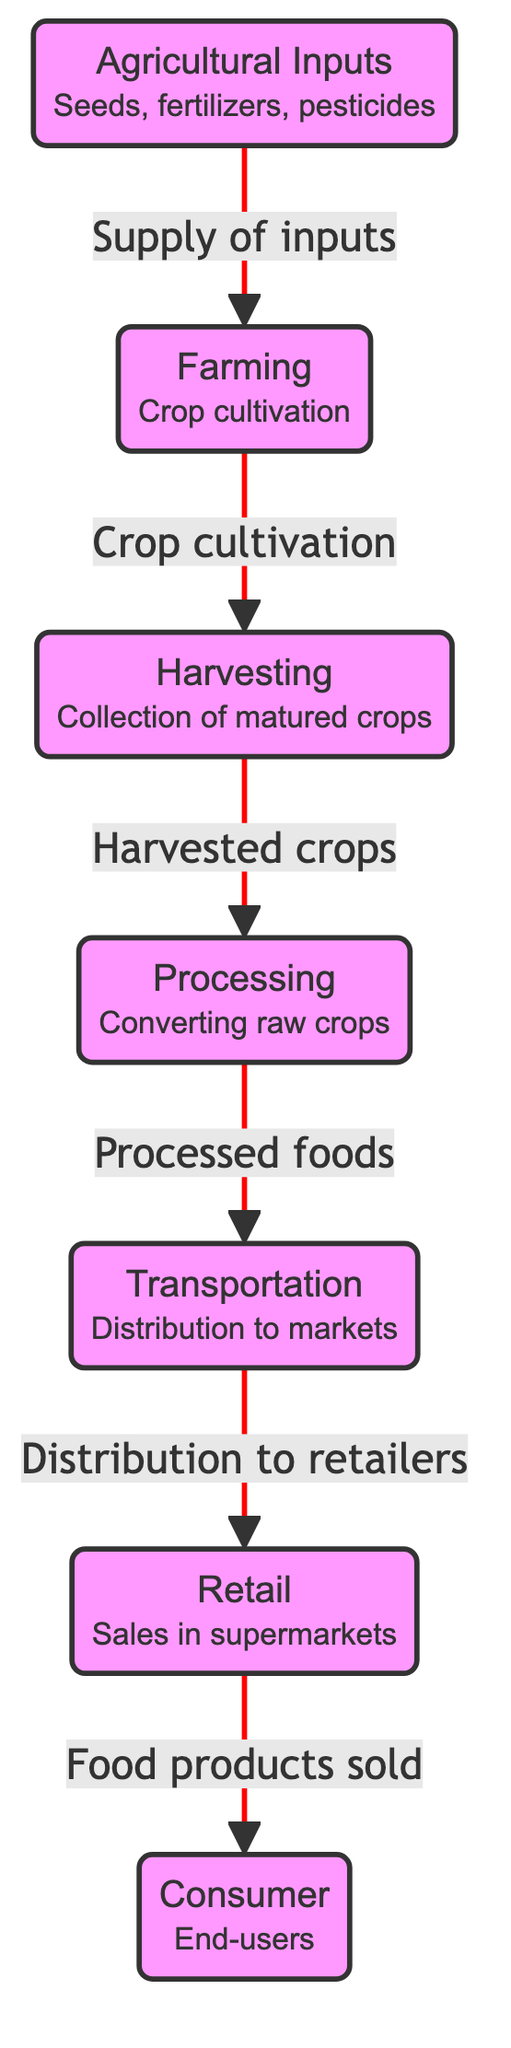What is the first node in the food chain? The first node in the food chain diagram represents "Agricultural Inputs," which includes seeds, fertilizers, and pesticides. It is the starting point of the supply chain depicted in the diagram.
Answer: Agricultural Inputs How many nodes are present in the diagram? The diagram contains seven nodes that illustrate different stages in the food supply chain, starting from agricultural inputs to the consumer.
Answer: 7 What does the arrow from Farming to Harvesting signify? The arrow indicates a direct relationship where Farming leads to the output of harvested crops, showing the flow in the supply chain from one stage to the next.
Answer: Crop cultivation Which node comes after Processing? The node that follows Processing in the diagram is Transportation, which represents the distribution of processed foods to markets.
Answer: Transportation What type of food products are sold in the Retail node? The Retail node represents "Food products sold," indicating that this stage involves the final sale of processed and raw food items to consumers.
Answer: Food products sold How many connections are there from the Processing node? The Processing node has one connection heading towards Transportation, showing that it transforms raw crops into processed foods for distribution.
Answer: 1 Which stage is the end-user in the supply chain? The end-user in this supply chain is represented in the Consumer node, which signifies the final recipient of food products once they are distributed through the previous stages.
Answer: Consumer What connects the Harvesting and Processing nodes? The connection between Harvesting and Processing demonstrates the flow of harvested crops into the Processing stage, emphasizing their dependency.
Answer: Harvested crops What is the significance of the red color in the diagram? The red color highlights the critical connections between nodes in the diagram, underscoring their importance in illustrating the flow of food from agricultural inputs to consumers.
Answer: Critical connections 